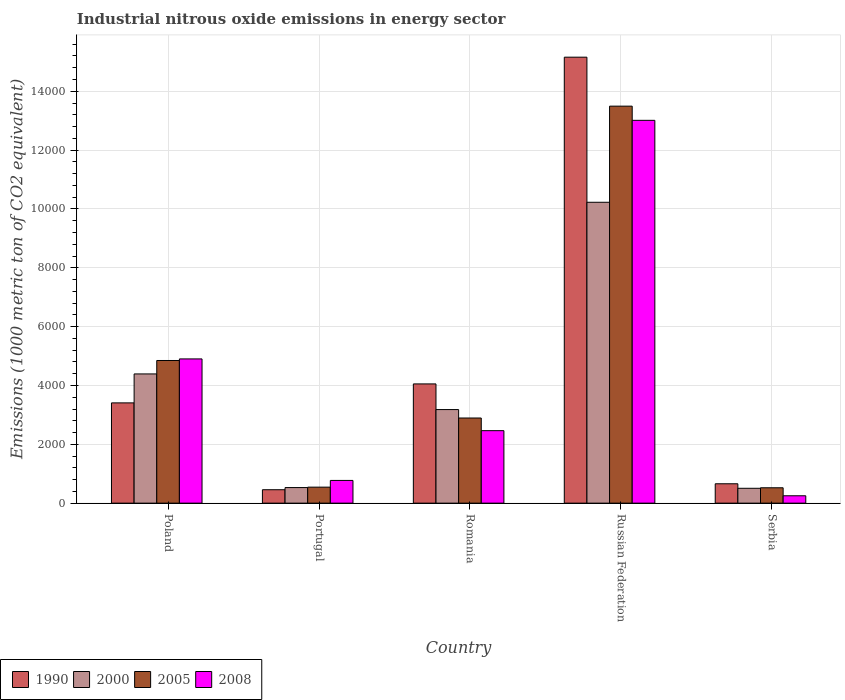How many different coloured bars are there?
Keep it short and to the point. 4. How many groups of bars are there?
Provide a short and direct response. 5. Are the number of bars per tick equal to the number of legend labels?
Provide a short and direct response. Yes. How many bars are there on the 5th tick from the left?
Offer a very short reply. 4. How many bars are there on the 2nd tick from the right?
Offer a terse response. 4. What is the amount of industrial nitrous oxide emitted in 2005 in Portugal?
Give a very brief answer. 543.9. Across all countries, what is the maximum amount of industrial nitrous oxide emitted in 2005?
Your answer should be very brief. 1.35e+04. Across all countries, what is the minimum amount of industrial nitrous oxide emitted in 2008?
Your response must be concise. 250.3. In which country was the amount of industrial nitrous oxide emitted in 2000 maximum?
Give a very brief answer. Russian Federation. In which country was the amount of industrial nitrous oxide emitted in 2008 minimum?
Your response must be concise. Serbia. What is the total amount of industrial nitrous oxide emitted in 2008 in the graph?
Your answer should be compact. 2.14e+04. What is the difference between the amount of industrial nitrous oxide emitted in 2005 in Romania and that in Russian Federation?
Your response must be concise. -1.06e+04. What is the difference between the amount of industrial nitrous oxide emitted in 1990 in Portugal and the amount of industrial nitrous oxide emitted in 2000 in Serbia?
Provide a succinct answer. -48.8. What is the average amount of industrial nitrous oxide emitted in 2005 per country?
Your answer should be compact. 4460.78. What is the difference between the amount of industrial nitrous oxide emitted of/in 2005 and amount of industrial nitrous oxide emitted of/in 2000 in Romania?
Offer a terse response. -286.8. What is the ratio of the amount of industrial nitrous oxide emitted in 2005 in Portugal to that in Romania?
Provide a short and direct response. 0.19. Is the amount of industrial nitrous oxide emitted in 1990 in Romania less than that in Russian Federation?
Ensure brevity in your answer.  Yes. What is the difference between the highest and the second highest amount of industrial nitrous oxide emitted in 2008?
Your response must be concise. 8109.6. What is the difference between the highest and the lowest amount of industrial nitrous oxide emitted in 1990?
Your answer should be compact. 1.47e+04. Is it the case that in every country, the sum of the amount of industrial nitrous oxide emitted in 2000 and amount of industrial nitrous oxide emitted in 1990 is greater than the amount of industrial nitrous oxide emitted in 2008?
Your response must be concise. Yes. Are all the bars in the graph horizontal?
Your answer should be very brief. No. What is the difference between two consecutive major ticks on the Y-axis?
Provide a short and direct response. 2000. What is the title of the graph?
Ensure brevity in your answer.  Industrial nitrous oxide emissions in energy sector. What is the label or title of the Y-axis?
Offer a terse response. Emissions (1000 metric ton of CO2 equivalent). What is the Emissions (1000 metric ton of CO2 equivalent) of 1990 in Poland?
Offer a very short reply. 3408.2. What is the Emissions (1000 metric ton of CO2 equivalent) of 2000 in Poland?
Provide a succinct answer. 4392.5. What is the Emissions (1000 metric ton of CO2 equivalent) in 2005 in Poland?
Give a very brief answer. 4849. What is the Emissions (1000 metric ton of CO2 equivalent) of 2008 in Poland?
Provide a succinct answer. 4902.7. What is the Emissions (1000 metric ton of CO2 equivalent) of 1990 in Portugal?
Your response must be concise. 456.2. What is the Emissions (1000 metric ton of CO2 equivalent) in 2000 in Portugal?
Give a very brief answer. 529.5. What is the Emissions (1000 metric ton of CO2 equivalent) in 2005 in Portugal?
Give a very brief answer. 543.9. What is the Emissions (1000 metric ton of CO2 equivalent) in 2008 in Portugal?
Offer a terse response. 772.3. What is the Emissions (1000 metric ton of CO2 equivalent) of 1990 in Romania?
Your answer should be very brief. 4052.7. What is the Emissions (1000 metric ton of CO2 equivalent) in 2000 in Romania?
Keep it short and to the point. 3180.9. What is the Emissions (1000 metric ton of CO2 equivalent) of 2005 in Romania?
Provide a succinct answer. 2894.1. What is the Emissions (1000 metric ton of CO2 equivalent) of 2008 in Romania?
Make the answer very short. 2463.8. What is the Emissions (1000 metric ton of CO2 equivalent) in 1990 in Russian Federation?
Your answer should be compact. 1.52e+04. What is the Emissions (1000 metric ton of CO2 equivalent) of 2000 in Russian Federation?
Your answer should be very brief. 1.02e+04. What is the Emissions (1000 metric ton of CO2 equivalent) of 2005 in Russian Federation?
Ensure brevity in your answer.  1.35e+04. What is the Emissions (1000 metric ton of CO2 equivalent) of 2008 in Russian Federation?
Your response must be concise. 1.30e+04. What is the Emissions (1000 metric ton of CO2 equivalent) of 1990 in Serbia?
Give a very brief answer. 658.4. What is the Emissions (1000 metric ton of CO2 equivalent) of 2000 in Serbia?
Provide a short and direct response. 505. What is the Emissions (1000 metric ton of CO2 equivalent) of 2005 in Serbia?
Your response must be concise. 522.3. What is the Emissions (1000 metric ton of CO2 equivalent) of 2008 in Serbia?
Provide a succinct answer. 250.3. Across all countries, what is the maximum Emissions (1000 metric ton of CO2 equivalent) of 1990?
Ensure brevity in your answer.  1.52e+04. Across all countries, what is the maximum Emissions (1000 metric ton of CO2 equivalent) of 2000?
Provide a short and direct response. 1.02e+04. Across all countries, what is the maximum Emissions (1000 metric ton of CO2 equivalent) in 2005?
Your answer should be compact. 1.35e+04. Across all countries, what is the maximum Emissions (1000 metric ton of CO2 equivalent) in 2008?
Offer a very short reply. 1.30e+04. Across all countries, what is the minimum Emissions (1000 metric ton of CO2 equivalent) of 1990?
Give a very brief answer. 456.2. Across all countries, what is the minimum Emissions (1000 metric ton of CO2 equivalent) of 2000?
Your answer should be compact. 505. Across all countries, what is the minimum Emissions (1000 metric ton of CO2 equivalent) of 2005?
Your answer should be very brief. 522.3. Across all countries, what is the minimum Emissions (1000 metric ton of CO2 equivalent) in 2008?
Offer a terse response. 250.3. What is the total Emissions (1000 metric ton of CO2 equivalent) of 1990 in the graph?
Provide a short and direct response. 2.37e+04. What is the total Emissions (1000 metric ton of CO2 equivalent) in 2000 in the graph?
Keep it short and to the point. 1.88e+04. What is the total Emissions (1000 metric ton of CO2 equivalent) of 2005 in the graph?
Your answer should be very brief. 2.23e+04. What is the total Emissions (1000 metric ton of CO2 equivalent) of 2008 in the graph?
Your answer should be compact. 2.14e+04. What is the difference between the Emissions (1000 metric ton of CO2 equivalent) of 1990 in Poland and that in Portugal?
Your response must be concise. 2952. What is the difference between the Emissions (1000 metric ton of CO2 equivalent) of 2000 in Poland and that in Portugal?
Give a very brief answer. 3863. What is the difference between the Emissions (1000 metric ton of CO2 equivalent) of 2005 in Poland and that in Portugal?
Keep it short and to the point. 4305.1. What is the difference between the Emissions (1000 metric ton of CO2 equivalent) in 2008 in Poland and that in Portugal?
Make the answer very short. 4130.4. What is the difference between the Emissions (1000 metric ton of CO2 equivalent) of 1990 in Poland and that in Romania?
Your answer should be very brief. -644.5. What is the difference between the Emissions (1000 metric ton of CO2 equivalent) in 2000 in Poland and that in Romania?
Ensure brevity in your answer.  1211.6. What is the difference between the Emissions (1000 metric ton of CO2 equivalent) in 2005 in Poland and that in Romania?
Make the answer very short. 1954.9. What is the difference between the Emissions (1000 metric ton of CO2 equivalent) in 2008 in Poland and that in Romania?
Your answer should be compact. 2438.9. What is the difference between the Emissions (1000 metric ton of CO2 equivalent) in 1990 in Poland and that in Russian Federation?
Offer a very short reply. -1.18e+04. What is the difference between the Emissions (1000 metric ton of CO2 equivalent) in 2000 in Poland and that in Russian Federation?
Offer a very short reply. -5834.6. What is the difference between the Emissions (1000 metric ton of CO2 equivalent) in 2005 in Poland and that in Russian Federation?
Your answer should be compact. -8645.6. What is the difference between the Emissions (1000 metric ton of CO2 equivalent) of 2008 in Poland and that in Russian Federation?
Offer a terse response. -8109.6. What is the difference between the Emissions (1000 metric ton of CO2 equivalent) in 1990 in Poland and that in Serbia?
Offer a very short reply. 2749.8. What is the difference between the Emissions (1000 metric ton of CO2 equivalent) of 2000 in Poland and that in Serbia?
Offer a terse response. 3887.5. What is the difference between the Emissions (1000 metric ton of CO2 equivalent) of 2005 in Poland and that in Serbia?
Ensure brevity in your answer.  4326.7. What is the difference between the Emissions (1000 metric ton of CO2 equivalent) in 2008 in Poland and that in Serbia?
Keep it short and to the point. 4652.4. What is the difference between the Emissions (1000 metric ton of CO2 equivalent) in 1990 in Portugal and that in Romania?
Keep it short and to the point. -3596.5. What is the difference between the Emissions (1000 metric ton of CO2 equivalent) in 2000 in Portugal and that in Romania?
Keep it short and to the point. -2651.4. What is the difference between the Emissions (1000 metric ton of CO2 equivalent) in 2005 in Portugal and that in Romania?
Give a very brief answer. -2350.2. What is the difference between the Emissions (1000 metric ton of CO2 equivalent) in 2008 in Portugal and that in Romania?
Make the answer very short. -1691.5. What is the difference between the Emissions (1000 metric ton of CO2 equivalent) in 1990 in Portugal and that in Russian Federation?
Your response must be concise. -1.47e+04. What is the difference between the Emissions (1000 metric ton of CO2 equivalent) in 2000 in Portugal and that in Russian Federation?
Provide a succinct answer. -9697.6. What is the difference between the Emissions (1000 metric ton of CO2 equivalent) of 2005 in Portugal and that in Russian Federation?
Offer a very short reply. -1.30e+04. What is the difference between the Emissions (1000 metric ton of CO2 equivalent) of 2008 in Portugal and that in Russian Federation?
Make the answer very short. -1.22e+04. What is the difference between the Emissions (1000 metric ton of CO2 equivalent) of 1990 in Portugal and that in Serbia?
Keep it short and to the point. -202.2. What is the difference between the Emissions (1000 metric ton of CO2 equivalent) in 2000 in Portugal and that in Serbia?
Ensure brevity in your answer.  24.5. What is the difference between the Emissions (1000 metric ton of CO2 equivalent) of 2005 in Portugal and that in Serbia?
Offer a terse response. 21.6. What is the difference between the Emissions (1000 metric ton of CO2 equivalent) of 2008 in Portugal and that in Serbia?
Make the answer very short. 522. What is the difference between the Emissions (1000 metric ton of CO2 equivalent) in 1990 in Romania and that in Russian Federation?
Give a very brief answer. -1.11e+04. What is the difference between the Emissions (1000 metric ton of CO2 equivalent) in 2000 in Romania and that in Russian Federation?
Offer a very short reply. -7046.2. What is the difference between the Emissions (1000 metric ton of CO2 equivalent) in 2005 in Romania and that in Russian Federation?
Your answer should be very brief. -1.06e+04. What is the difference between the Emissions (1000 metric ton of CO2 equivalent) in 2008 in Romania and that in Russian Federation?
Your answer should be compact. -1.05e+04. What is the difference between the Emissions (1000 metric ton of CO2 equivalent) of 1990 in Romania and that in Serbia?
Your answer should be very brief. 3394.3. What is the difference between the Emissions (1000 metric ton of CO2 equivalent) of 2000 in Romania and that in Serbia?
Offer a terse response. 2675.9. What is the difference between the Emissions (1000 metric ton of CO2 equivalent) in 2005 in Romania and that in Serbia?
Offer a terse response. 2371.8. What is the difference between the Emissions (1000 metric ton of CO2 equivalent) of 2008 in Romania and that in Serbia?
Your response must be concise. 2213.5. What is the difference between the Emissions (1000 metric ton of CO2 equivalent) in 1990 in Russian Federation and that in Serbia?
Keep it short and to the point. 1.45e+04. What is the difference between the Emissions (1000 metric ton of CO2 equivalent) of 2000 in Russian Federation and that in Serbia?
Your answer should be very brief. 9722.1. What is the difference between the Emissions (1000 metric ton of CO2 equivalent) in 2005 in Russian Federation and that in Serbia?
Make the answer very short. 1.30e+04. What is the difference between the Emissions (1000 metric ton of CO2 equivalent) of 2008 in Russian Federation and that in Serbia?
Keep it short and to the point. 1.28e+04. What is the difference between the Emissions (1000 metric ton of CO2 equivalent) of 1990 in Poland and the Emissions (1000 metric ton of CO2 equivalent) of 2000 in Portugal?
Make the answer very short. 2878.7. What is the difference between the Emissions (1000 metric ton of CO2 equivalent) in 1990 in Poland and the Emissions (1000 metric ton of CO2 equivalent) in 2005 in Portugal?
Offer a terse response. 2864.3. What is the difference between the Emissions (1000 metric ton of CO2 equivalent) of 1990 in Poland and the Emissions (1000 metric ton of CO2 equivalent) of 2008 in Portugal?
Provide a short and direct response. 2635.9. What is the difference between the Emissions (1000 metric ton of CO2 equivalent) of 2000 in Poland and the Emissions (1000 metric ton of CO2 equivalent) of 2005 in Portugal?
Provide a succinct answer. 3848.6. What is the difference between the Emissions (1000 metric ton of CO2 equivalent) of 2000 in Poland and the Emissions (1000 metric ton of CO2 equivalent) of 2008 in Portugal?
Ensure brevity in your answer.  3620.2. What is the difference between the Emissions (1000 metric ton of CO2 equivalent) in 2005 in Poland and the Emissions (1000 metric ton of CO2 equivalent) in 2008 in Portugal?
Your answer should be compact. 4076.7. What is the difference between the Emissions (1000 metric ton of CO2 equivalent) in 1990 in Poland and the Emissions (1000 metric ton of CO2 equivalent) in 2000 in Romania?
Ensure brevity in your answer.  227.3. What is the difference between the Emissions (1000 metric ton of CO2 equivalent) in 1990 in Poland and the Emissions (1000 metric ton of CO2 equivalent) in 2005 in Romania?
Offer a very short reply. 514.1. What is the difference between the Emissions (1000 metric ton of CO2 equivalent) in 1990 in Poland and the Emissions (1000 metric ton of CO2 equivalent) in 2008 in Romania?
Your answer should be very brief. 944.4. What is the difference between the Emissions (1000 metric ton of CO2 equivalent) in 2000 in Poland and the Emissions (1000 metric ton of CO2 equivalent) in 2005 in Romania?
Offer a very short reply. 1498.4. What is the difference between the Emissions (1000 metric ton of CO2 equivalent) in 2000 in Poland and the Emissions (1000 metric ton of CO2 equivalent) in 2008 in Romania?
Give a very brief answer. 1928.7. What is the difference between the Emissions (1000 metric ton of CO2 equivalent) in 2005 in Poland and the Emissions (1000 metric ton of CO2 equivalent) in 2008 in Romania?
Your answer should be compact. 2385.2. What is the difference between the Emissions (1000 metric ton of CO2 equivalent) in 1990 in Poland and the Emissions (1000 metric ton of CO2 equivalent) in 2000 in Russian Federation?
Give a very brief answer. -6818.9. What is the difference between the Emissions (1000 metric ton of CO2 equivalent) in 1990 in Poland and the Emissions (1000 metric ton of CO2 equivalent) in 2005 in Russian Federation?
Offer a terse response. -1.01e+04. What is the difference between the Emissions (1000 metric ton of CO2 equivalent) of 1990 in Poland and the Emissions (1000 metric ton of CO2 equivalent) of 2008 in Russian Federation?
Your answer should be very brief. -9604.1. What is the difference between the Emissions (1000 metric ton of CO2 equivalent) of 2000 in Poland and the Emissions (1000 metric ton of CO2 equivalent) of 2005 in Russian Federation?
Your response must be concise. -9102.1. What is the difference between the Emissions (1000 metric ton of CO2 equivalent) in 2000 in Poland and the Emissions (1000 metric ton of CO2 equivalent) in 2008 in Russian Federation?
Keep it short and to the point. -8619.8. What is the difference between the Emissions (1000 metric ton of CO2 equivalent) in 2005 in Poland and the Emissions (1000 metric ton of CO2 equivalent) in 2008 in Russian Federation?
Your answer should be compact. -8163.3. What is the difference between the Emissions (1000 metric ton of CO2 equivalent) in 1990 in Poland and the Emissions (1000 metric ton of CO2 equivalent) in 2000 in Serbia?
Your answer should be very brief. 2903.2. What is the difference between the Emissions (1000 metric ton of CO2 equivalent) in 1990 in Poland and the Emissions (1000 metric ton of CO2 equivalent) in 2005 in Serbia?
Provide a succinct answer. 2885.9. What is the difference between the Emissions (1000 metric ton of CO2 equivalent) of 1990 in Poland and the Emissions (1000 metric ton of CO2 equivalent) of 2008 in Serbia?
Give a very brief answer. 3157.9. What is the difference between the Emissions (1000 metric ton of CO2 equivalent) in 2000 in Poland and the Emissions (1000 metric ton of CO2 equivalent) in 2005 in Serbia?
Offer a very short reply. 3870.2. What is the difference between the Emissions (1000 metric ton of CO2 equivalent) in 2000 in Poland and the Emissions (1000 metric ton of CO2 equivalent) in 2008 in Serbia?
Offer a very short reply. 4142.2. What is the difference between the Emissions (1000 metric ton of CO2 equivalent) in 2005 in Poland and the Emissions (1000 metric ton of CO2 equivalent) in 2008 in Serbia?
Your answer should be compact. 4598.7. What is the difference between the Emissions (1000 metric ton of CO2 equivalent) in 1990 in Portugal and the Emissions (1000 metric ton of CO2 equivalent) in 2000 in Romania?
Provide a succinct answer. -2724.7. What is the difference between the Emissions (1000 metric ton of CO2 equivalent) of 1990 in Portugal and the Emissions (1000 metric ton of CO2 equivalent) of 2005 in Romania?
Offer a very short reply. -2437.9. What is the difference between the Emissions (1000 metric ton of CO2 equivalent) in 1990 in Portugal and the Emissions (1000 metric ton of CO2 equivalent) in 2008 in Romania?
Give a very brief answer. -2007.6. What is the difference between the Emissions (1000 metric ton of CO2 equivalent) in 2000 in Portugal and the Emissions (1000 metric ton of CO2 equivalent) in 2005 in Romania?
Give a very brief answer. -2364.6. What is the difference between the Emissions (1000 metric ton of CO2 equivalent) of 2000 in Portugal and the Emissions (1000 metric ton of CO2 equivalent) of 2008 in Romania?
Your answer should be compact. -1934.3. What is the difference between the Emissions (1000 metric ton of CO2 equivalent) of 2005 in Portugal and the Emissions (1000 metric ton of CO2 equivalent) of 2008 in Romania?
Your response must be concise. -1919.9. What is the difference between the Emissions (1000 metric ton of CO2 equivalent) in 1990 in Portugal and the Emissions (1000 metric ton of CO2 equivalent) in 2000 in Russian Federation?
Your answer should be very brief. -9770.9. What is the difference between the Emissions (1000 metric ton of CO2 equivalent) in 1990 in Portugal and the Emissions (1000 metric ton of CO2 equivalent) in 2005 in Russian Federation?
Your response must be concise. -1.30e+04. What is the difference between the Emissions (1000 metric ton of CO2 equivalent) of 1990 in Portugal and the Emissions (1000 metric ton of CO2 equivalent) of 2008 in Russian Federation?
Your answer should be compact. -1.26e+04. What is the difference between the Emissions (1000 metric ton of CO2 equivalent) in 2000 in Portugal and the Emissions (1000 metric ton of CO2 equivalent) in 2005 in Russian Federation?
Ensure brevity in your answer.  -1.30e+04. What is the difference between the Emissions (1000 metric ton of CO2 equivalent) in 2000 in Portugal and the Emissions (1000 metric ton of CO2 equivalent) in 2008 in Russian Federation?
Ensure brevity in your answer.  -1.25e+04. What is the difference between the Emissions (1000 metric ton of CO2 equivalent) of 2005 in Portugal and the Emissions (1000 metric ton of CO2 equivalent) of 2008 in Russian Federation?
Make the answer very short. -1.25e+04. What is the difference between the Emissions (1000 metric ton of CO2 equivalent) of 1990 in Portugal and the Emissions (1000 metric ton of CO2 equivalent) of 2000 in Serbia?
Keep it short and to the point. -48.8. What is the difference between the Emissions (1000 metric ton of CO2 equivalent) in 1990 in Portugal and the Emissions (1000 metric ton of CO2 equivalent) in 2005 in Serbia?
Give a very brief answer. -66.1. What is the difference between the Emissions (1000 metric ton of CO2 equivalent) of 1990 in Portugal and the Emissions (1000 metric ton of CO2 equivalent) of 2008 in Serbia?
Provide a succinct answer. 205.9. What is the difference between the Emissions (1000 metric ton of CO2 equivalent) of 2000 in Portugal and the Emissions (1000 metric ton of CO2 equivalent) of 2005 in Serbia?
Your response must be concise. 7.2. What is the difference between the Emissions (1000 metric ton of CO2 equivalent) of 2000 in Portugal and the Emissions (1000 metric ton of CO2 equivalent) of 2008 in Serbia?
Your answer should be very brief. 279.2. What is the difference between the Emissions (1000 metric ton of CO2 equivalent) in 2005 in Portugal and the Emissions (1000 metric ton of CO2 equivalent) in 2008 in Serbia?
Ensure brevity in your answer.  293.6. What is the difference between the Emissions (1000 metric ton of CO2 equivalent) in 1990 in Romania and the Emissions (1000 metric ton of CO2 equivalent) in 2000 in Russian Federation?
Keep it short and to the point. -6174.4. What is the difference between the Emissions (1000 metric ton of CO2 equivalent) of 1990 in Romania and the Emissions (1000 metric ton of CO2 equivalent) of 2005 in Russian Federation?
Your answer should be very brief. -9441.9. What is the difference between the Emissions (1000 metric ton of CO2 equivalent) in 1990 in Romania and the Emissions (1000 metric ton of CO2 equivalent) in 2008 in Russian Federation?
Ensure brevity in your answer.  -8959.6. What is the difference between the Emissions (1000 metric ton of CO2 equivalent) of 2000 in Romania and the Emissions (1000 metric ton of CO2 equivalent) of 2005 in Russian Federation?
Your answer should be compact. -1.03e+04. What is the difference between the Emissions (1000 metric ton of CO2 equivalent) in 2000 in Romania and the Emissions (1000 metric ton of CO2 equivalent) in 2008 in Russian Federation?
Provide a short and direct response. -9831.4. What is the difference between the Emissions (1000 metric ton of CO2 equivalent) in 2005 in Romania and the Emissions (1000 metric ton of CO2 equivalent) in 2008 in Russian Federation?
Provide a succinct answer. -1.01e+04. What is the difference between the Emissions (1000 metric ton of CO2 equivalent) in 1990 in Romania and the Emissions (1000 metric ton of CO2 equivalent) in 2000 in Serbia?
Offer a terse response. 3547.7. What is the difference between the Emissions (1000 metric ton of CO2 equivalent) in 1990 in Romania and the Emissions (1000 metric ton of CO2 equivalent) in 2005 in Serbia?
Keep it short and to the point. 3530.4. What is the difference between the Emissions (1000 metric ton of CO2 equivalent) of 1990 in Romania and the Emissions (1000 metric ton of CO2 equivalent) of 2008 in Serbia?
Your answer should be compact. 3802.4. What is the difference between the Emissions (1000 metric ton of CO2 equivalent) of 2000 in Romania and the Emissions (1000 metric ton of CO2 equivalent) of 2005 in Serbia?
Give a very brief answer. 2658.6. What is the difference between the Emissions (1000 metric ton of CO2 equivalent) in 2000 in Romania and the Emissions (1000 metric ton of CO2 equivalent) in 2008 in Serbia?
Your answer should be very brief. 2930.6. What is the difference between the Emissions (1000 metric ton of CO2 equivalent) of 2005 in Romania and the Emissions (1000 metric ton of CO2 equivalent) of 2008 in Serbia?
Keep it short and to the point. 2643.8. What is the difference between the Emissions (1000 metric ton of CO2 equivalent) of 1990 in Russian Federation and the Emissions (1000 metric ton of CO2 equivalent) of 2000 in Serbia?
Provide a succinct answer. 1.47e+04. What is the difference between the Emissions (1000 metric ton of CO2 equivalent) of 1990 in Russian Federation and the Emissions (1000 metric ton of CO2 equivalent) of 2005 in Serbia?
Make the answer very short. 1.46e+04. What is the difference between the Emissions (1000 metric ton of CO2 equivalent) in 1990 in Russian Federation and the Emissions (1000 metric ton of CO2 equivalent) in 2008 in Serbia?
Keep it short and to the point. 1.49e+04. What is the difference between the Emissions (1000 metric ton of CO2 equivalent) in 2000 in Russian Federation and the Emissions (1000 metric ton of CO2 equivalent) in 2005 in Serbia?
Provide a short and direct response. 9704.8. What is the difference between the Emissions (1000 metric ton of CO2 equivalent) in 2000 in Russian Federation and the Emissions (1000 metric ton of CO2 equivalent) in 2008 in Serbia?
Give a very brief answer. 9976.8. What is the difference between the Emissions (1000 metric ton of CO2 equivalent) in 2005 in Russian Federation and the Emissions (1000 metric ton of CO2 equivalent) in 2008 in Serbia?
Ensure brevity in your answer.  1.32e+04. What is the average Emissions (1000 metric ton of CO2 equivalent) in 1990 per country?
Offer a terse response. 4747. What is the average Emissions (1000 metric ton of CO2 equivalent) of 2000 per country?
Provide a succinct answer. 3767. What is the average Emissions (1000 metric ton of CO2 equivalent) in 2005 per country?
Your answer should be very brief. 4460.78. What is the average Emissions (1000 metric ton of CO2 equivalent) in 2008 per country?
Your answer should be compact. 4280.28. What is the difference between the Emissions (1000 metric ton of CO2 equivalent) in 1990 and Emissions (1000 metric ton of CO2 equivalent) in 2000 in Poland?
Give a very brief answer. -984.3. What is the difference between the Emissions (1000 metric ton of CO2 equivalent) in 1990 and Emissions (1000 metric ton of CO2 equivalent) in 2005 in Poland?
Ensure brevity in your answer.  -1440.8. What is the difference between the Emissions (1000 metric ton of CO2 equivalent) of 1990 and Emissions (1000 metric ton of CO2 equivalent) of 2008 in Poland?
Ensure brevity in your answer.  -1494.5. What is the difference between the Emissions (1000 metric ton of CO2 equivalent) of 2000 and Emissions (1000 metric ton of CO2 equivalent) of 2005 in Poland?
Make the answer very short. -456.5. What is the difference between the Emissions (1000 metric ton of CO2 equivalent) of 2000 and Emissions (1000 metric ton of CO2 equivalent) of 2008 in Poland?
Provide a succinct answer. -510.2. What is the difference between the Emissions (1000 metric ton of CO2 equivalent) of 2005 and Emissions (1000 metric ton of CO2 equivalent) of 2008 in Poland?
Offer a very short reply. -53.7. What is the difference between the Emissions (1000 metric ton of CO2 equivalent) of 1990 and Emissions (1000 metric ton of CO2 equivalent) of 2000 in Portugal?
Give a very brief answer. -73.3. What is the difference between the Emissions (1000 metric ton of CO2 equivalent) in 1990 and Emissions (1000 metric ton of CO2 equivalent) in 2005 in Portugal?
Your response must be concise. -87.7. What is the difference between the Emissions (1000 metric ton of CO2 equivalent) of 1990 and Emissions (1000 metric ton of CO2 equivalent) of 2008 in Portugal?
Your answer should be very brief. -316.1. What is the difference between the Emissions (1000 metric ton of CO2 equivalent) of 2000 and Emissions (1000 metric ton of CO2 equivalent) of 2005 in Portugal?
Your response must be concise. -14.4. What is the difference between the Emissions (1000 metric ton of CO2 equivalent) in 2000 and Emissions (1000 metric ton of CO2 equivalent) in 2008 in Portugal?
Provide a short and direct response. -242.8. What is the difference between the Emissions (1000 metric ton of CO2 equivalent) of 2005 and Emissions (1000 metric ton of CO2 equivalent) of 2008 in Portugal?
Give a very brief answer. -228.4. What is the difference between the Emissions (1000 metric ton of CO2 equivalent) of 1990 and Emissions (1000 metric ton of CO2 equivalent) of 2000 in Romania?
Provide a succinct answer. 871.8. What is the difference between the Emissions (1000 metric ton of CO2 equivalent) of 1990 and Emissions (1000 metric ton of CO2 equivalent) of 2005 in Romania?
Your response must be concise. 1158.6. What is the difference between the Emissions (1000 metric ton of CO2 equivalent) in 1990 and Emissions (1000 metric ton of CO2 equivalent) in 2008 in Romania?
Make the answer very short. 1588.9. What is the difference between the Emissions (1000 metric ton of CO2 equivalent) in 2000 and Emissions (1000 metric ton of CO2 equivalent) in 2005 in Romania?
Offer a very short reply. 286.8. What is the difference between the Emissions (1000 metric ton of CO2 equivalent) of 2000 and Emissions (1000 metric ton of CO2 equivalent) of 2008 in Romania?
Provide a succinct answer. 717.1. What is the difference between the Emissions (1000 metric ton of CO2 equivalent) in 2005 and Emissions (1000 metric ton of CO2 equivalent) in 2008 in Romania?
Your answer should be very brief. 430.3. What is the difference between the Emissions (1000 metric ton of CO2 equivalent) in 1990 and Emissions (1000 metric ton of CO2 equivalent) in 2000 in Russian Federation?
Your answer should be compact. 4932.4. What is the difference between the Emissions (1000 metric ton of CO2 equivalent) in 1990 and Emissions (1000 metric ton of CO2 equivalent) in 2005 in Russian Federation?
Offer a very short reply. 1664.9. What is the difference between the Emissions (1000 metric ton of CO2 equivalent) of 1990 and Emissions (1000 metric ton of CO2 equivalent) of 2008 in Russian Federation?
Provide a succinct answer. 2147.2. What is the difference between the Emissions (1000 metric ton of CO2 equivalent) of 2000 and Emissions (1000 metric ton of CO2 equivalent) of 2005 in Russian Federation?
Make the answer very short. -3267.5. What is the difference between the Emissions (1000 metric ton of CO2 equivalent) of 2000 and Emissions (1000 metric ton of CO2 equivalent) of 2008 in Russian Federation?
Keep it short and to the point. -2785.2. What is the difference between the Emissions (1000 metric ton of CO2 equivalent) of 2005 and Emissions (1000 metric ton of CO2 equivalent) of 2008 in Russian Federation?
Give a very brief answer. 482.3. What is the difference between the Emissions (1000 metric ton of CO2 equivalent) in 1990 and Emissions (1000 metric ton of CO2 equivalent) in 2000 in Serbia?
Your answer should be compact. 153.4. What is the difference between the Emissions (1000 metric ton of CO2 equivalent) in 1990 and Emissions (1000 metric ton of CO2 equivalent) in 2005 in Serbia?
Your response must be concise. 136.1. What is the difference between the Emissions (1000 metric ton of CO2 equivalent) in 1990 and Emissions (1000 metric ton of CO2 equivalent) in 2008 in Serbia?
Give a very brief answer. 408.1. What is the difference between the Emissions (1000 metric ton of CO2 equivalent) of 2000 and Emissions (1000 metric ton of CO2 equivalent) of 2005 in Serbia?
Provide a short and direct response. -17.3. What is the difference between the Emissions (1000 metric ton of CO2 equivalent) of 2000 and Emissions (1000 metric ton of CO2 equivalent) of 2008 in Serbia?
Your answer should be compact. 254.7. What is the difference between the Emissions (1000 metric ton of CO2 equivalent) of 2005 and Emissions (1000 metric ton of CO2 equivalent) of 2008 in Serbia?
Your answer should be compact. 272. What is the ratio of the Emissions (1000 metric ton of CO2 equivalent) in 1990 in Poland to that in Portugal?
Your answer should be compact. 7.47. What is the ratio of the Emissions (1000 metric ton of CO2 equivalent) of 2000 in Poland to that in Portugal?
Provide a succinct answer. 8.3. What is the ratio of the Emissions (1000 metric ton of CO2 equivalent) in 2005 in Poland to that in Portugal?
Your answer should be very brief. 8.92. What is the ratio of the Emissions (1000 metric ton of CO2 equivalent) of 2008 in Poland to that in Portugal?
Ensure brevity in your answer.  6.35. What is the ratio of the Emissions (1000 metric ton of CO2 equivalent) of 1990 in Poland to that in Romania?
Make the answer very short. 0.84. What is the ratio of the Emissions (1000 metric ton of CO2 equivalent) in 2000 in Poland to that in Romania?
Give a very brief answer. 1.38. What is the ratio of the Emissions (1000 metric ton of CO2 equivalent) in 2005 in Poland to that in Romania?
Your answer should be very brief. 1.68. What is the ratio of the Emissions (1000 metric ton of CO2 equivalent) in 2008 in Poland to that in Romania?
Your response must be concise. 1.99. What is the ratio of the Emissions (1000 metric ton of CO2 equivalent) of 1990 in Poland to that in Russian Federation?
Keep it short and to the point. 0.22. What is the ratio of the Emissions (1000 metric ton of CO2 equivalent) in 2000 in Poland to that in Russian Federation?
Ensure brevity in your answer.  0.43. What is the ratio of the Emissions (1000 metric ton of CO2 equivalent) of 2005 in Poland to that in Russian Federation?
Give a very brief answer. 0.36. What is the ratio of the Emissions (1000 metric ton of CO2 equivalent) of 2008 in Poland to that in Russian Federation?
Make the answer very short. 0.38. What is the ratio of the Emissions (1000 metric ton of CO2 equivalent) in 1990 in Poland to that in Serbia?
Make the answer very short. 5.18. What is the ratio of the Emissions (1000 metric ton of CO2 equivalent) of 2000 in Poland to that in Serbia?
Keep it short and to the point. 8.7. What is the ratio of the Emissions (1000 metric ton of CO2 equivalent) of 2005 in Poland to that in Serbia?
Give a very brief answer. 9.28. What is the ratio of the Emissions (1000 metric ton of CO2 equivalent) of 2008 in Poland to that in Serbia?
Provide a short and direct response. 19.59. What is the ratio of the Emissions (1000 metric ton of CO2 equivalent) of 1990 in Portugal to that in Romania?
Offer a very short reply. 0.11. What is the ratio of the Emissions (1000 metric ton of CO2 equivalent) of 2000 in Portugal to that in Romania?
Your answer should be very brief. 0.17. What is the ratio of the Emissions (1000 metric ton of CO2 equivalent) in 2005 in Portugal to that in Romania?
Offer a very short reply. 0.19. What is the ratio of the Emissions (1000 metric ton of CO2 equivalent) in 2008 in Portugal to that in Romania?
Ensure brevity in your answer.  0.31. What is the ratio of the Emissions (1000 metric ton of CO2 equivalent) in 1990 in Portugal to that in Russian Federation?
Provide a succinct answer. 0.03. What is the ratio of the Emissions (1000 metric ton of CO2 equivalent) of 2000 in Portugal to that in Russian Federation?
Keep it short and to the point. 0.05. What is the ratio of the Emissions (1000 metric ton of CO2 equivalent) of 2005 in Portugal to that in Russian Federation?
Keep it short and to the point. 0.04. What is the ratio of the Emissions (1000 metric ton of CO2 equivalent) of 2008 in Portugal to that in Russian Federation?
Your response must be concise. 0.06. What is the ratio of the Emissions (1000 metric ton of CO2 equivalent) in 1990 in Portugal to that in Serbia?
Ensure brevity in your answer.  0.69. What is the ratio of the Emissions (1000 metric ton of CO2 equivalent) in 2000 in Portugal to that in Serbia?
Make the answer very short. 1.05. What is the ratio of the Emissions (1000 metric ton of CO2 equivalent) in 2005 in Portugal to that in Serbia?
Give a very brief answer. 1.04. What is the ratio of the Emissions (1000 metric ton of CO2 equivalent) in 2008 in Portugal to that in Serbia?
Make the answer very short. 3.09. What is the ratio of the Emissions (1000 metric ton of CO2 equivalent) of 1990 in Romania to that in Russian Federation?
Provide a succinct answer. 0.27. What is the ratio of the Emissions (1000 metric ton of CO2 equivalent) in 2000 in Romania to that in Russian Federation?
Offer a very short reply. 0.31. What is the ratio of the Emissions (1000 metric ton of CO2 equivalent) of 2005 in Romania to that in Russian Federation?
Make the answer very short. 0.21. What is the ratio of the Emissions (1000 metric ton of CO2 equivalent) in 2008 in Romania to that in Russian Federation?
Provide a short and direct response. 0.19. What is the ratio of the Emissions (1000 metric ton of CO2 equivalent) of 1990 in Romania to that in Serbia?
Make the answer very short. 6.16. What is the ratio of the Emissions (1000 metric ton of CO2 equivalent) in 2000 in Romania to that in Serbia?
Offer a very short reply. 6.3. What is the ratio of the Emissions (1000 metric ton of CO2 equivalent) of 2005 in Romania to that in Serbia?
Offer a very short reply. 5.54. What is the ratio of the Emissions (1000 metric ton of CO2 equivalent) in 2008 in Romania to that in Serbia?
Offer a very short reply. 9.84. What is the ratio of the Emissions (1000 metric ton of CO2 equivalent) of 1990 in Russian Federation to that in Serbia?
Give a very brief answer. 23.02. What is the ratio of the Emissions (1000 metric ton of CO2 equivalent) of 2000 in Russian Federation to that in Serbia?
Offer a very short reply. 20.25. What is the ratio of the Emissions (1000 metric ton of CO2 equivalent) in 2005 in Russian Federation to that in Serbia?
Offer a terse response. 25.84. What is the ratio of the Emissions (1000 metric ton of CO2 equivalent) of 2008 in Russian Federation to that in Serbia?
Keep it short and to the point. 51.99. What is the difference between the highest and the second highest Emissions (1000 metric ton of CO2 equivalent) of 1990?
Provide a succinct answer. 1.11e+04. What is the difference between the highest and the second highest Emissions (1000 metric ton of CO2 equivalent) of 2000?
Provide a short and direct response. 5834.6. What is the difference between the highest and the second highest Emissions (1000 metric ton of CO2 equivalent) of 2005?
Provide a succinct answer. 8645.6. What is the difference between the highest and the second highest Emissions (1000 metric ton of CO2 equivalent) in 2008?
Provide a short and direct response. 8109.6. What is the difference between the highest and the lowest Emissions (1000 metric ton of CO2 equivalent) of 1990?
Keep it short and to the point. 1.47e+04. What is the difference between the highest and the lowest Emissions (1000 metric ton of CO2 equivalent) in 2000?
Offer a terse response. 9722.1. What is the difference between the highest and the lowest Emissions (1000 metric ton of CO2 equivalent) in 2005?
Give a very brief answer. 1.30e+04. What is the difference between the highest and the lowest Emissions (1000 metric ton of CO2 equivalent) in 2008?
Offer a very short reply. 1.28e+04. 